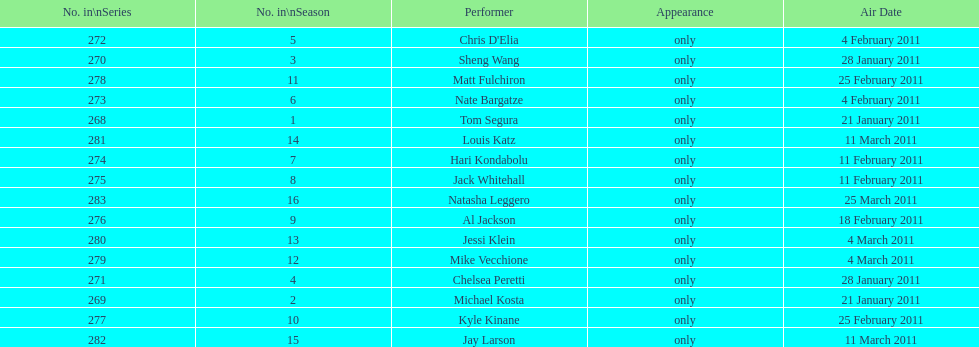Parse the table in full. {'header': ['No. in\\nSeries', 'No. in\\nSeason', 'Performer', 'Appearance', 'Air Date'], 'rows': [['272', '5', "Chris D'Elia", 'only', '4 February 2011'], ['270', '3', 'Sheng Wang', 'only', '28 January 2011'], ['278', '11', 'Matt Fulchiron', 'only', '25 February 2011'], ['273', '6', 'Nate Bargatze', 'only', '4 February 2011'], ['268', '1', 'Tom Segura', 'only', '21 January 2011'], ['281', '14', 'Louis Katz', 'only', '11 March 2011'], ['274', '7', 'Hari Kondabolu', 'only', '11 February 2011'], ['275', '8', 'Jack Whitehall', 'only', '11 February 2011'], ['283', '16', 'Natasha Leggero', 'only', '25 March 2011'], ['276', '9', 'Al Jackson', 'only', '18 February 2011'], ['280', '13', 'Jessi Klein', 'only', '4 March 2011'], ['279', '12', 'Mike Vecchione', 'only', '4 March 2011'], ['271', '4', 'Chelsea Peretti', 'only', '28 January 2011'], ['269', '2', 'Michael Kosta', 'only', '21 January 2011'], ['277', '10', 'Kyle Kinane', 'only', '25 February 2011'], ['282', '15', 'Jay Larson', 'only', '11 March 2011']]} Which month had the most performers? February. 